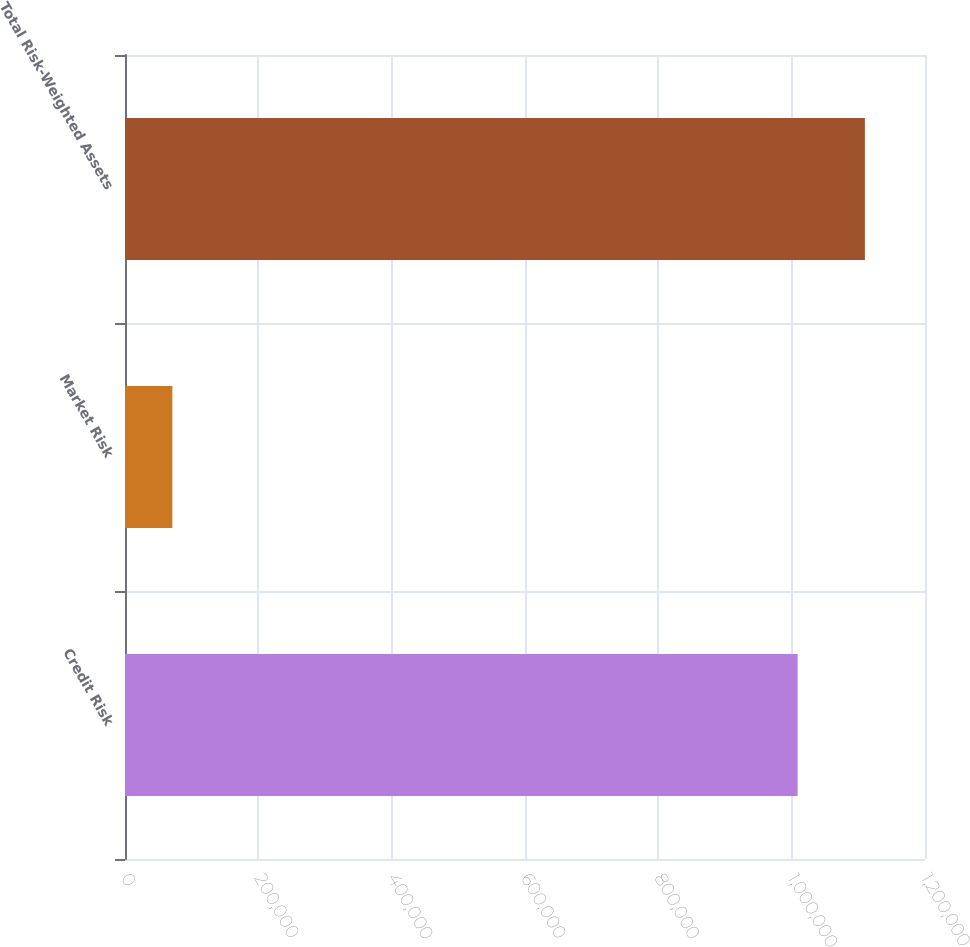Convert chart. <chart><loc_0><loc_0><loc_500><loc_500><bar_chart><fcel>Credit Risk<fcel>Market Risk<fcel>Total Risk-Weighted Assets<nl><fcel>1.00895e+06<fcel>71015<fcel>1.10985e+06<nl></chart> 